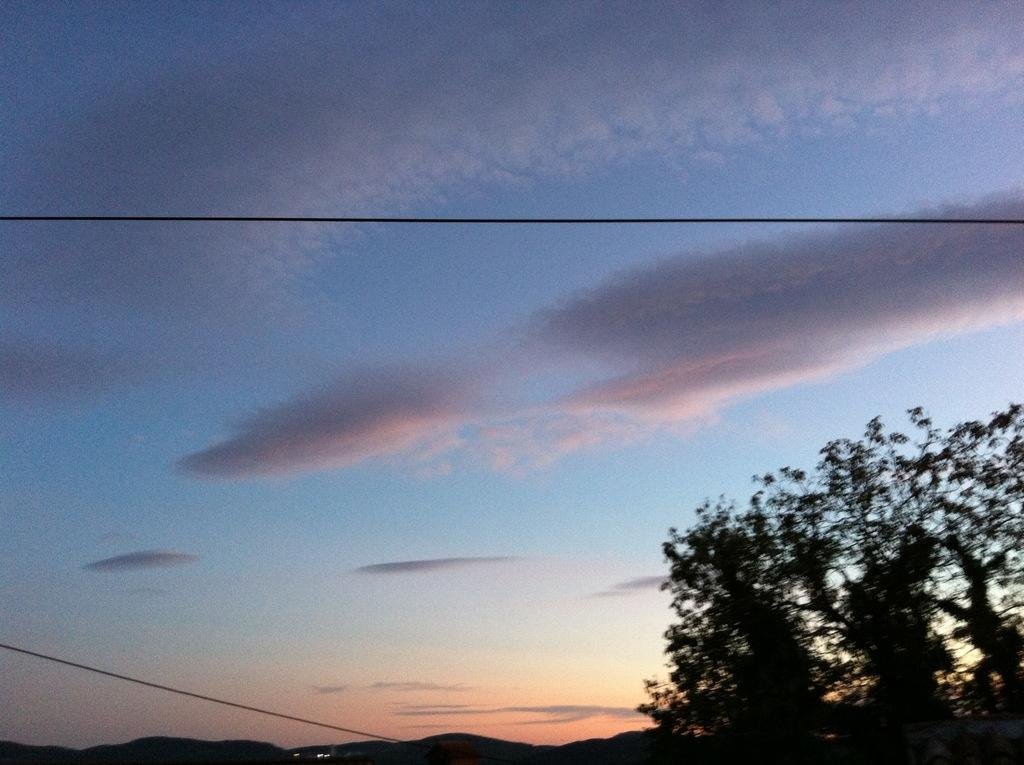What time of day is depicted in the image? The image shows a morning view. What type of vegetation can be seen in the image? There is a tree in the image. What type of landscape is visible in the image? There are hills visible in the image. What is visible in the sky in the image? The sky is visible in the image, and there are clouds present. What can be seen coming from the sun in the image? Sun rays are present in the image. What type of curtain is hanging in front of the hills in the image? There is no curtain present in the image; the hills are visible without any obstructions. What memories does the image evoke for the viewer? The image does not evoke any specific memories, as it is a general landscape scene. 